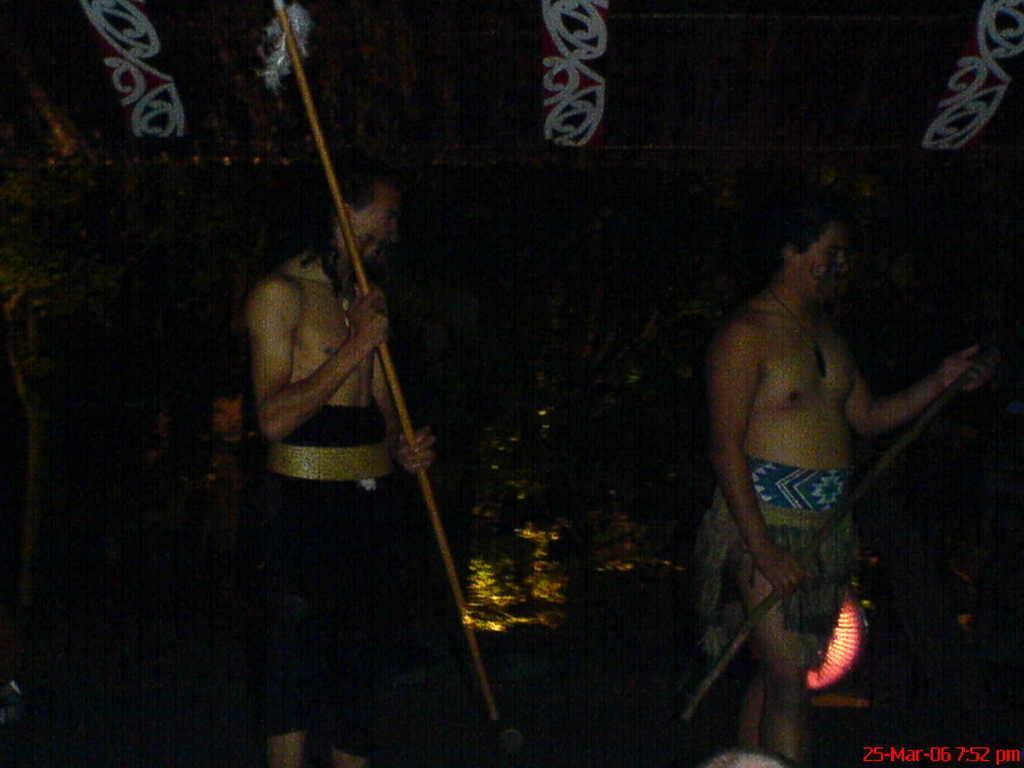How would you summarize this image in a sentence or two? In the image two persons standing and holding sticks. Behind them there are some trees. 